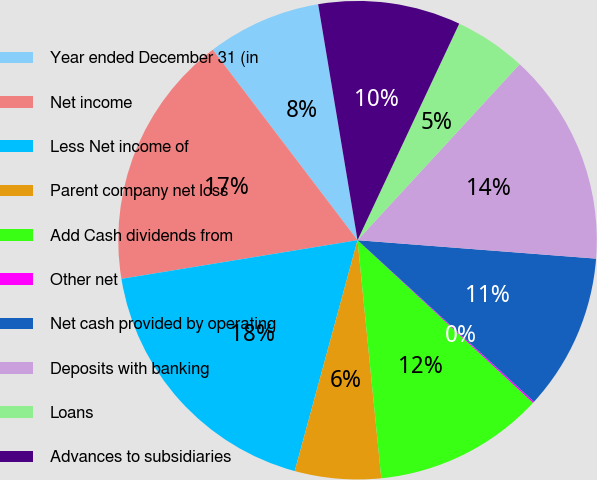<chart> <loc_0><loc_0><loc_500><loc_500><pie_chart><fcel>Year ended December 31 (in<fcel>Net income<fcel>Less Net income of<fcel>Parent company net loss<fcel>Add Cash dividends from<fcel>Other net<fcel>Net cash provided by operating<fcel>Deposits with banking<fcel>Loans<fcel>Advances to subsidiaries<nl><fcel>7.71%<fcel>17.24%<fcel>18.19%<fcel>5.81%<fcel>11.52%<fcel>0.1%<fcel>10.57%<fcel>14.38%<fcel>4.86%<fcel>9.62%<nl></chart> 